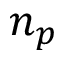<formula> <loc_0><loc_0><loc_500><loc_500>n _ { p }</formula> 